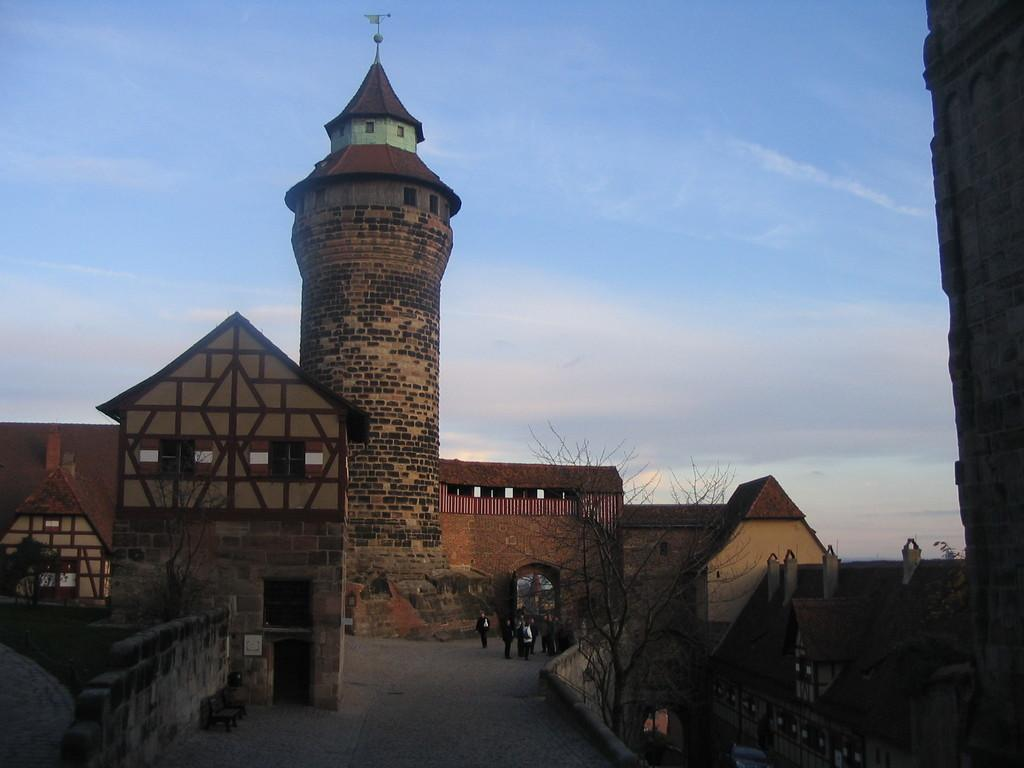What type of structures can be seen in the image? There are buildings in the image. What other natural elements are present in the image? There are trees in the image. Are there any living beings visible in the image? Yes, there are people in the image. What type of surface is present under the people and trees? There is pavement in the image. How many benches are located at the bottom of the image? There are two benches at the bottom of the image. What can be seen in the sky in the image? The sky is visible in the image, and there are clouds in the sky. Where are the cattle grazing in the image? There are no cattle present in the image. What type of fowl can be seen flying in the sky? There are no fowl visible in the image; only clouds can be seen in the sky. 